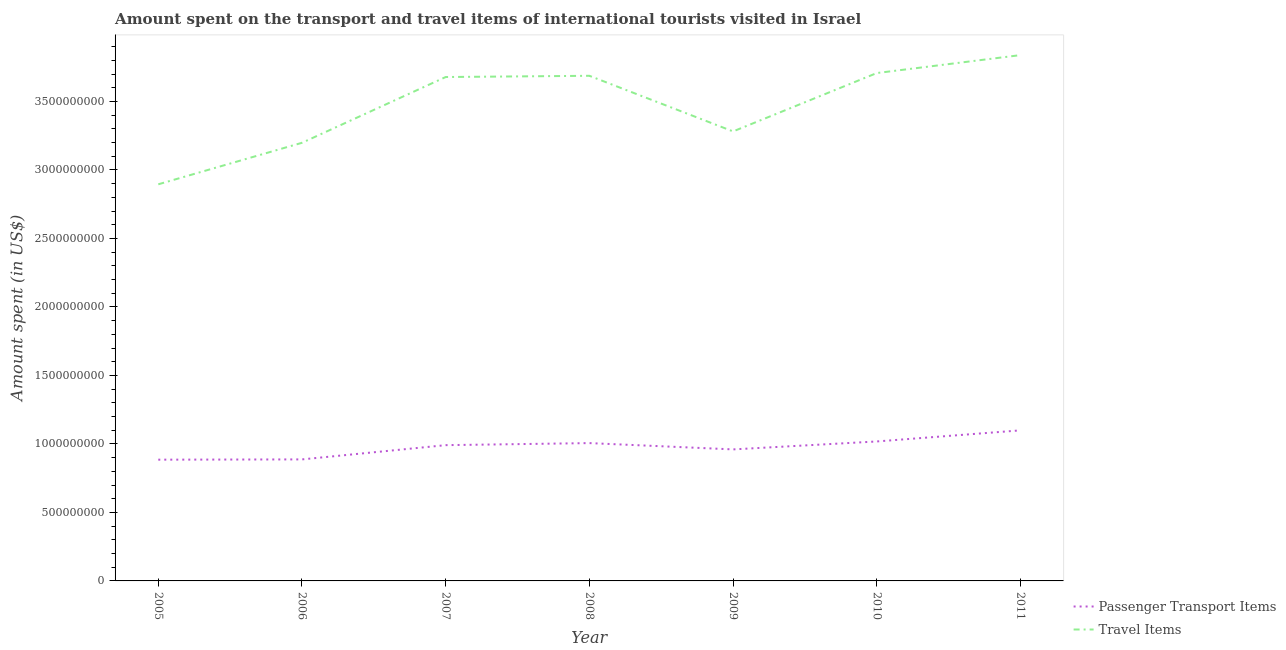How many different coloured lines are there?
Provide a succinct answer. 2. What is the amount spent on passenger transport items in 2006?
Make the answer very short. 8.87e+08. Across all years, what is the maximum amount spent on passenger transport items?
Provide a short and direct response. 1.10e+09. Across all years, what is the minimum amount spent on passenger transport items?
Provide a short and direct response. 8.85e+08. In which year was the amount spent in travel items minimum?
Your answer should be very brief. 2005. What is the total amount spent in travel items in the graph?
Make the answer very short. 2.43e+1. What is the difference between the amount spent in travel items in 2006 and that in 2011?
Keep it short and to the point. -6.40e+08. What is the difference between the amount spent in travel items in 2007 and the amount spent on passenger transport items in 2006?
Provide a short and direct response. 2.79e+09. What is the average amount spent on passenger transport items per year?
Ensure brevity in your answer.  9.78e+08. In the year 2008, what is the difference between the amount spent in travel items and amount spent on passenger transport items?
Ensure brevity in your answer.  2.68e+09. What is the ratio of the amount spent in travel items in 2008 to that in 2011?
Make the answer very short. 0.96. What is the difference between the highest and the second highest amount spent in travel items?
Keep it short and to the point. 1.31e+08. What is the difference between the highest and the lowest amount spent in travel items?
Your response must be concise. 9.43e+08. In how many years, is the amount spent in travel items greater than the average amount spent in travel items taken over all years?
Offer a terse response. 4. Does the amount spent in travel items monotonically increase over the years?
Offer a terse response. No. Is the amount spent in travel items strictly less than the amount spent on passenger transport items over the years?
Keep it short and to the point. No. What is the difference between two consecutive major ticks on the Y-axis?
Your answer should be compact. 5.00e+08. Are the values on the major ticks of Y-axis written in scientific E-notation?
Your response must be concise. No. Does the graph contain any zero values?
Give a very brief answer. No. Where does the legend appear in the graph?
Your answer should be very brief. Bottom right. How many legend labels are there?
Your answer should be very brief. 2. How are the legend labels stacked?
Provide a short and direct response. Vertical. What is the title of the graph?
Provide a succinct answer. Amount spent on the transport and travel items of international tourists visited in Israel. What is the label or title of the X-axis?
Give a very brief answer. Year. What is the label or title of the Y-axis?
Keep it short and to the point. Amount spent (in US$). What is the Amount spent (in US$) in Passenger Transport Items in 2005?
Offer a terse response. 8.85e+08. What is the Amount spent (in US$) in Travel Items in 2005?
Your answer should be very brief. 2.90e+09. What is the Amount spent (in US$) of Passenger Transport Items in 2006?
Provide a short and direct response. 8.87e+08. What is the Amount spent (in US$) in Travel Items in 2006?
Provide a succinct answer. 3.20e+09. What is the Amount spent (in US$) in Passenger Transport Items in 2007?
Your response must be concise. 9.91e+08. What is the Amount spent (in US$) in Travel Items in 2007?
Provide a short and direct response. 3.68e+09. What is the Amount spent (in US$) in Passenger Transport Items in 2008?
Provide a short and direct response. 1.01e+09. What is the Amount spent (in US$) in Travel Items in 2008?
Ensure brevity in your answer.  3.69e+09. What is the Amount spent (in US$) in Passenger Transport Items in 2009?
Keep it short and to the point. 9.60e+08. What is the Amount spent (in US$) in Travel Items in 2009?
Your response must be concise. 3.28e+09. What is the Amount spent (in US$) of Passenger Transport Items in 2010?
Make the answer very short. 1.02e+09. What is the Amount spent (in US$) of Travel Items in 2010?
Make the answer very short. 3.71e+09. What is the Amount spent (in US$) of Passenger Transport Items in 2011?
Offer a very short reply. 1.10e+09. What is the Amount spent (in US$) of Travel Items in 2011?
Offer a very short reply. 3.84e+09. Across all years, what is the maximum Amount spent (in US$) in Passenger Transport Items?
Offer a very short reply. 1.10e+09. Across all years, what is the maximum Amount spent (in US$) in Travel Items?
Ensure brevity in your answer.  3.84e+09. Across all years, what is the minimum Amount spent (in US$) of Passenger Transport Items?
Offer a terse response. 8.85e+08. Across all years, what is the minimum Amount spent (in US$) in Travel Items?
Provide a succinct answer. 2.90e+09. What is the total Amount spent (in US$) in Passenger Transport Items in the graph?
Provide a succinct answer. 6.85e+09. What is the total Amount spent (in US$) of Travel Items in the graph?
Your answer should be very brief. 2.43e+1. What is the difference between the Amount spent (in US$) of Travel Items in 2005 and that in 2006?
Give a very brief answer. -3.03e+08. What is the difference between the Amount spent (in US$) in Passenger Transport Items in 2005 and that in 2007?
Make the answer very short. -1.06e+08. What is the difference between the Amount spent (in US$) in Travel Items in 2005 and that in 2007?
Make the answer very short. -7.83e+08. What is the difference between the Amount spent (in US$) of Passenger Transport Items in 2005 and that in 2008?
Give a very brief answer. -1.21e+08. What is the difference between the Amount spent (in US$) in Travel Items in 2005 and that in 2008?
Offer a very short reply. -7.92e+08. What is the difference between the Amount spent (in US$) in Passenger Transport Items in 2005 and that in 2009?
Your response must be concise. -7.50e+07. What is the difference between the Amount spent (in US$) of Travel Items in 2005 and that in 2009?
Your answer should be very brief. -3.86e+08. What is the difference between the Amount spent (in US$) of Passenger Transport Items in 2005 and that in 2010?
Make the answer very short. -1.33e+08. What is the difference between the Amount spent (in US$) of Travel Items in 2005 and that in 2010?
Your answer should be compact. -8.12e+08. What is the difference between the Amount spent (in US$) of Passenger Transport Items in 2005 and that in 2011?
Your response must be concise. -2.14e+08. What is the difference between the Amount spent (in US$) in Travel Items in 2005 and that in 2011?
Provide a succinct answer. -9.43e+08. What is the difference between the Amount spent (in US$) in Passenger Transport Items in 2006 and that in 2007?
Offer a terse response. -1.04e+08. What is the difference between the Amount spent (in US$) of Travel Items in 2006 and that in 2007?
Provide a succinct answer. -4.80e+08. What is the difference between the Amount spent (in US$) in Passenger Transport Items in 2006 and that in 2008?
Offer a terse response. -1.19e+08. What is the difference between the Amount spent (in US$) of Travel Items in 2006 and that in 2008?
Your response must be concise. -4.89e+08. What is the difference between the Amount spent (in US$) in Passenger Transport Items in 2006 and that in 2009?
Your answer should be compact. -7.30e+07. What is the difference between the Amount spent (in US$) of Travel Items in 2006 and that in 2009?
Keep it short and to the point. -8.30e+07. What is the difference between the Amount spent (in US$) of Passenger Transport Items in 2006 and that in 2010?
Your answer should be compact. -1.31e+08. What is the difference between the Amount spent (in US$) of Travel Items in 2006 and that in 2010?
Offer a terse response. -5.09e+08. What is the difference between the Amount spent (in US$) of Passenger Transport Items in 2006 and that in 2011?
Make the answer very short. -2.12e+08. What is the difference between the Amount spent (in US$) in Travel Items in 2006 and that in 2011?
Ensure brevity in your answer.  -6.40e+08. What is the difference between the Amount spent (in US$) in Passenger Transport Items in 2007 and that in 2008?
Your answer should be very brief. -1.50e+07. What is the difference between the Amount spent (in US$) in Travel Items in 2007 and that in 2008?
Provide a short and direct response. -9.00e+06. What is the difference between the Amount spent (in US$) of Passenger Transport Items in 2007 and that in 2009?
Provide a short and direct response. 3.10e+07. What is the difference between the Amount spent (in US$) in Travel Items in 2007 and that in 2009?
Make the answer very short. 3.97e+08. What is the difference between the Amount spent (in US$) in Passenger Transport Items in 2007 and that in 2010?
Provide a short and direct response. -2.70e+07. What is the difference between the Amount spent (in US$) of Travel Items in 2007 and that in 2010?
Ensure brevity in your answer.  -2.90e+07. What is the difference between the Amount spent (in US$) of Passenger Transport Items in 2007 and that in 2011?
Your response must be concise. -1.08e+08. What is the difference between the Amount spent (in US$) in Travel Items in 2007 and that in 2011?
Provide a short and direct response. -1.60e+08. What is the difference between the Amount spent (in US$) in Passenger Transport Items in 2008 and that in 2009?
Offer a terse response. 4.60e+07. What is the difference between the Amount spent (in US$) of Travel Items in 2008 and that in 2009?
Offer a very short reply. 4.06e+08. What is the difference between the Amount spent (in US$) of Passenger Transport Items in 2008 and that in 2010?
Your response must be concise. -1.20e+07. What is the difference between the Amount spent (in US$) in Travel Items in 2008 and that in 2010?
Your answer should be compact. -2.00e+07. What is the difference between the Amount spent (in US$) in Passenger Transport Items in 2008 and that in 2011?
Your answer should be compact. -9.30e+07. What is the difference between the Amount spent (in US$) of Travel Items in 2008 and that in 2011?
Make the answer very short. -1.51e+08. What is the difference between the Amount spent (in US$) in Passenger Transport Items in 2009 and that in 2010?
Keep it short and to the point. -5.80e+07. What is the difference between the Amount spent (in US$) of Travel Items in 2009 and that in 2010?
Your answer should be very brief. -4.26e+08. What is the difference between the Amount spent (in US$) in Passenger Transport Items in 2009 and that in 2011?
Your answer should be very brief. -1.39e+08. What is the difference between the Amount spent (in US$) in Travel Items in 2009 and that in 2011?
Provide a succinct answer. -5.57e+08. What is the difference between the Amount spent (in US$) of Passenger Transport Items in 2010 and that in 2011?
Make the answer very short. -8.10e+07. What is the difference between the Amount spent (in US$) of Travel Items in 2010 and that in 2011?
Your answer should be compact. -1.31e+08. What is the difference between the Amount spent (in US$) of Passenger Transport Items in 2005 and the Amount spent (in US$) of Travel Items in 2006?
Ensure brevity in your answer.  -2.31e+09. What is the difference between the Amount spent (in US$) of Passenger Transport Items in 2005 and the Amount spent (in US$) of Travel Items in 2007?
Your answer should be compact. -2.79e+09. What is the difference between the Amount spent (in US$) in Passenger Transport Items in 2005 and the Amount spent (in US$) in Travel Items in 2008?
Make the answer very short. -2.80e+09. What is the difference between the Amount spent (in US$) in Passenger Transport Items in 2005 and the Amount spent (in US$) in Travel Items in 2009?
Ensure brevity in your answer.  -2.40e+09. What is the difference between the Amount spent (in US$) in Passenger Transport Items in 2005 and the Amount spent (in US$) in Travel Items in 2010?
Your response must be concise. -2.82e+09. What is the difference between the Amount spent (in US$) of Passenger Transport Items in 2005 and the Amount spent (in US$) of Travel Items in 2011?
Your response must be concise. -2.95e+09. What is the difference between the Amount spent (in US$) of Passenger Transport Items in 2006 and the Amount spent (in US$) of Travel Items in 2007?
Offer a very short reply. -2.79e+09. What is the difference between the Amount spent (in US$) of Passenger Transport Items in 2006 and the Amount spent (in US$) of Travel Items in 2008?
Provide a short and direct response. -2.80e+09. What is the difference between the Amount spent (in US$) in Passenger Transport Items in 2006 and the Amount spent (in US$) in Travel Items in 2009?
Your response must be concise. -2.39e+09. What is the difference between the Amount spent (in US$) in Passenger Transport Items in 2006 and the Amount spent (in US$) in Travel Items in 2010?
Offer a terse response. -2.82e+09. What is the difference between the Amount spent (in US$) in Passenger Transport Items in 2006 and the Amount spent (in US$) in Travel Items in 2011?
Ensure brevity in your answer.  -2.95e+09. What is the difference between the Amount spent (in US$) in Passenger Transport Items in 2007 and the Amount spent (in US$) in Travel Items in 2008?
Make the answer very short. -2.70e+09. What is the difference between the Amount spent (in US$) of Passenger Transport Items in 2007 and the Amount spent (in US$) of Travel Items in 2009?
Provide a succinct answer. -2.29e+09. What is the difference between the Amount spent (in US$) in Passenger Transport Items in 2007 and the Amount spent (in US$) in Travel Items in 2010?
Offer a terse response. -2.72e+09. What is the difference between the Amount spent (in US$) of Passenger Transport Items in 2007 and the Amount spent (in US$) of Travel Items in 2011?
Keep it short and to the point. -2.85e+09. What is the difference between the Amount spent (in US$) of Passenger Transport Items in 2008 and the Amount spent (in US$) of Travel Items in 2009?
Make the answer very short. -2.28e+09. What is the difference between the Amount spent (in US$) in Passenger Transport Items in 2008 and the Amount spent (in US$) in Travel Items in 2010?
Make the answer very short. -2.70e+09. What is the difference between the Amount spent (in US$) in Passenger Transport Items in 2008 and the Amount spent (in US$) in Travel Items in 2011?
Make the answer very short. -2.83e+09. What is the difference between the Amount spent (in US$) in Passenger Transport Items in 2009 and the Amount spent (in US$) in Travel Items in 2010?
Ensure brevity in your answer.  -2.75e+09. What is the difference between the Amount spent (in US$) of Passenger Transport Items in 2009 and the Amount spent (in US$) of Travel Items in 2011?
Ensure brevity in your answer.  -2.88e+09. What is the difference between the Amount spent (in US$) of Passenger Transport Items in 2010 and the Amount spent (in US$) of Travel Items in 2011?
Ensure brevity in your answer.  -2.82e+09. What is the average Amount spent (in US$) of Passenger Transport Items per year?
Offer a very short reply. 9.78e+08. What is the average Amount spent (in US$) in Travel Items per year?
Provide a succinct answer. 3.47e+09. In the year 2005, what is the difference between the Amount spent (in US$) of Passenger Transport Items and Amount spent (in US$) of Travel Items?
Ensure brevity in your answer.  -2.01e+09. In the year 2006, what is the difference between the Amount spent (in US$) in Passenger Transport Items and Amount spent (in US$) in Travel Items?
Offer a terse response. -2.31e+09. In the year 2007, what is the difference between the Amount spent (in US$) of Passenger Transport Items and Amount spent (in US$) of Travel Items?
Keep it short and to the point. -2.69e+09. In the year 2008, what is the difference between the Amount spent (in US$) in Passenger Transport Items and Amount spent (in US$) in Travel Items?
Offer a terse response. -2.68e+09. In the year 2009, what is the difference between the Amount spent (in US$) of Passenger Transport Items and Amount spent (in US$) of Travel Items?
Provide a succinct answer. -2.32e+09. In the year 2010, what is the difference between the Amount spent (in US$) of Passenger Transport Items and Amount spent (in US$) of Travel Items?
Your response must be concise. -2.69e+09. In the year 2011, what is the difference between the Amount spent (in US$) in Passenger Transport Items and Amount spent (in US$) in Travel Items?
Ensure brevity in your answer.  -2.74e+09. What is the ratio of the Amount spent (in US$) in Passenger Transport Items in 2005 to that in 2006?
Keep it short and to the point. 1. What is the ratio of the Amount spent (in US$) of Travel Items in 2005 to that in 2006?
Your response must be concise. 0.91. What is the ratio of the Amount spent (in US$) in Passenger Transport Items in 2005 to that in 2007?
Make the answer very short. 0.89. What is the ratio of the Amount spent (in US$) of Travel Items in 2005 to that in 2007?
Give a very brief answer. 0.79. What is the ratio of the Amount spent (in US$) in Passenger Transport Items in 2005 to that in 2008?
Your answer should be very brief. 0.88. What is the ratio of the Amount spent (in US$) in Travel Items in 2005 to that in 2008?
Your response must be concise. 0.79. What is the ratio of the Amount spent (in US$) in Passenger Transport Items in 2005 to that in 2009?
Ensure brevity in your answer.  0.92. What is the ratio of the Amount spent (in US$) in Travel Items in 2005 to that in 2009?
Offer a very short reply. 0.88. What is the ratio of the Amount spent (in US$) in Passenger Transport Items in 2005 to that in 2010?
Provide a short and direct response. 0.87. What is the ratio of the Amount spent (in US$) in Travel Items in 2005 to that in 2010?
Keep it short and to the point. 0.78. What is the ratio of the Amount spent (in US$) of Passenger Transport Items in 2005 to that in 2011?
Ensure brevity in your answer.  0.81. What is the ratio of the Amount spent (in US$) of Travel Items in 2005 to that in 2011?
Your answer should be compact. 0.75. What is the ratio of the Amount spent (in US$) in Passenger Transport Items in 2006 to that in 2007?
Provide a succinct answer. 0.9. What is the ratio of the Amount spent (in US$) in Travel Items in 2006 to that in 2007?
Your response must be concise. 0.87. What is the ratio of the Amount spent (in US$) of Passenger Transport Items in 2006 to that in 2008?
Offer a terse response. 0.88. What is the ratio of the Amount spent (in US$) in Travel Items in 2006 to that in 2008?
Provide a succinct answer. 0.87. What is the ratio of the Amount spent (in US$) in Passenger Transport Items in 2006 to that in 2009?
Your response must be concise. 0.92. What is the ratio of the Amount spent (in US$) of Travel Items in 2006 to that in 2009?
Offer a very short reply. 0.97. What is the ratio of the Amount spent (in US$) of Passenger Transport Items in 2006 to that in 2010?
Give a very brief answer. 0.87. What is the ratio of the Amount spent (in US$) in Travel Items in 2006 to that in 2010?
Ensure brevity in your answer.  0.86. What is the ratio of the Amount spent (in US$) in Passenger Transport Items in 2006 to that in 2011?
Keep it short and to the point. 0.81. What is the ratio of the Amount spent (in US$) of Travel Items in 2006 to that in 2011?
Make the answer very short. 0.83. What is the ratio of the Amount spent (in US$) in Passenger Transport Items in 2007 to that in 2008?
Keep it short and to the point. 0.99. What is the ratio of the Amount spent (in US$) of Passenger Transport Items in 2007 to that in 2009?
Provide a short and direct response. 1.03. What is the ratio of the Amount spent (in US$) of Travel Items in 2007 to that in 2009?
Your answer should be compact. 1.12. What is the ratio of the Amount spent (in US$) of Passenger Transport Items in 2007 to that in 2010?
Give a very brief answer. 0.97. What is the ratio of the Amount spent (in US$) in Passenger Transport Items in 2007 to that in 2011?
Ensure brevity in your answer.  0.9. What is the ratio of the Amount spent (in US$) of Passenger Transport Items in 2008 to that in 2009?
Make the answer very short. 1.05. What is the ratio of the Amount spent (in US$) in Travel Items in 2008 to that in 2009?
Offer a terse response. 1.12. What is the ratio of the Amount spent (in US$) in Passenger Transport Items in 2008 to that in 2011?
Offer a terse response. 0.92. What is the ratio of the Amount spent (in US$) of Travel Items in 2008 to that in 2011?
Give a very brief answer. 0.96. What is the ratio of the Amount spent (in US$) in Passenger Transport Items in 2009 to that in 2010?
Offer a very short reply. 0.94. What is the ratio of the Amount spent (in US$) of Travel Items in 2009 to that in 2010?
Offer a very short reply. 0.89. What is the ratio of the Amount spent (in US$) of Passenger Transport Items in 2009 to that in 2011?
Provide a short and direct response. 0.87. What is the ratio of the Amount spent (in US$) of Travel Items in 2009 to that in 2011?
Provide a short and direct response. 0.85. What is the ratio of the Amount spent (in US$) in Passenger Transport Items in 2010 to that in 2011?
Give a very brief answer. 0.93. What is the ratio of the Amount spent (in US$) in Travel Items in 2010 to that in 2011?
Your response must be concise. 0.97. What is the difference between the highest and the second highest Amount spent (in US$) in Passenger Transport Items?
Keep it short and to the point. 8.10e+07. What is the difference between the highest and the second highest Amount spent (in US$) of Travel Items?
Offer a very short reply. 1.31e+08. What is the difference between the highest and the lowest Amount spent (in US$) of Passenger Transport Items?
Ensure brevity in your answer.  2.14e+08. What is the difference between the highest and the lowest Amount spent (in US$) in Travel Items?
Provide a short and direct response. 9.43e+08. 